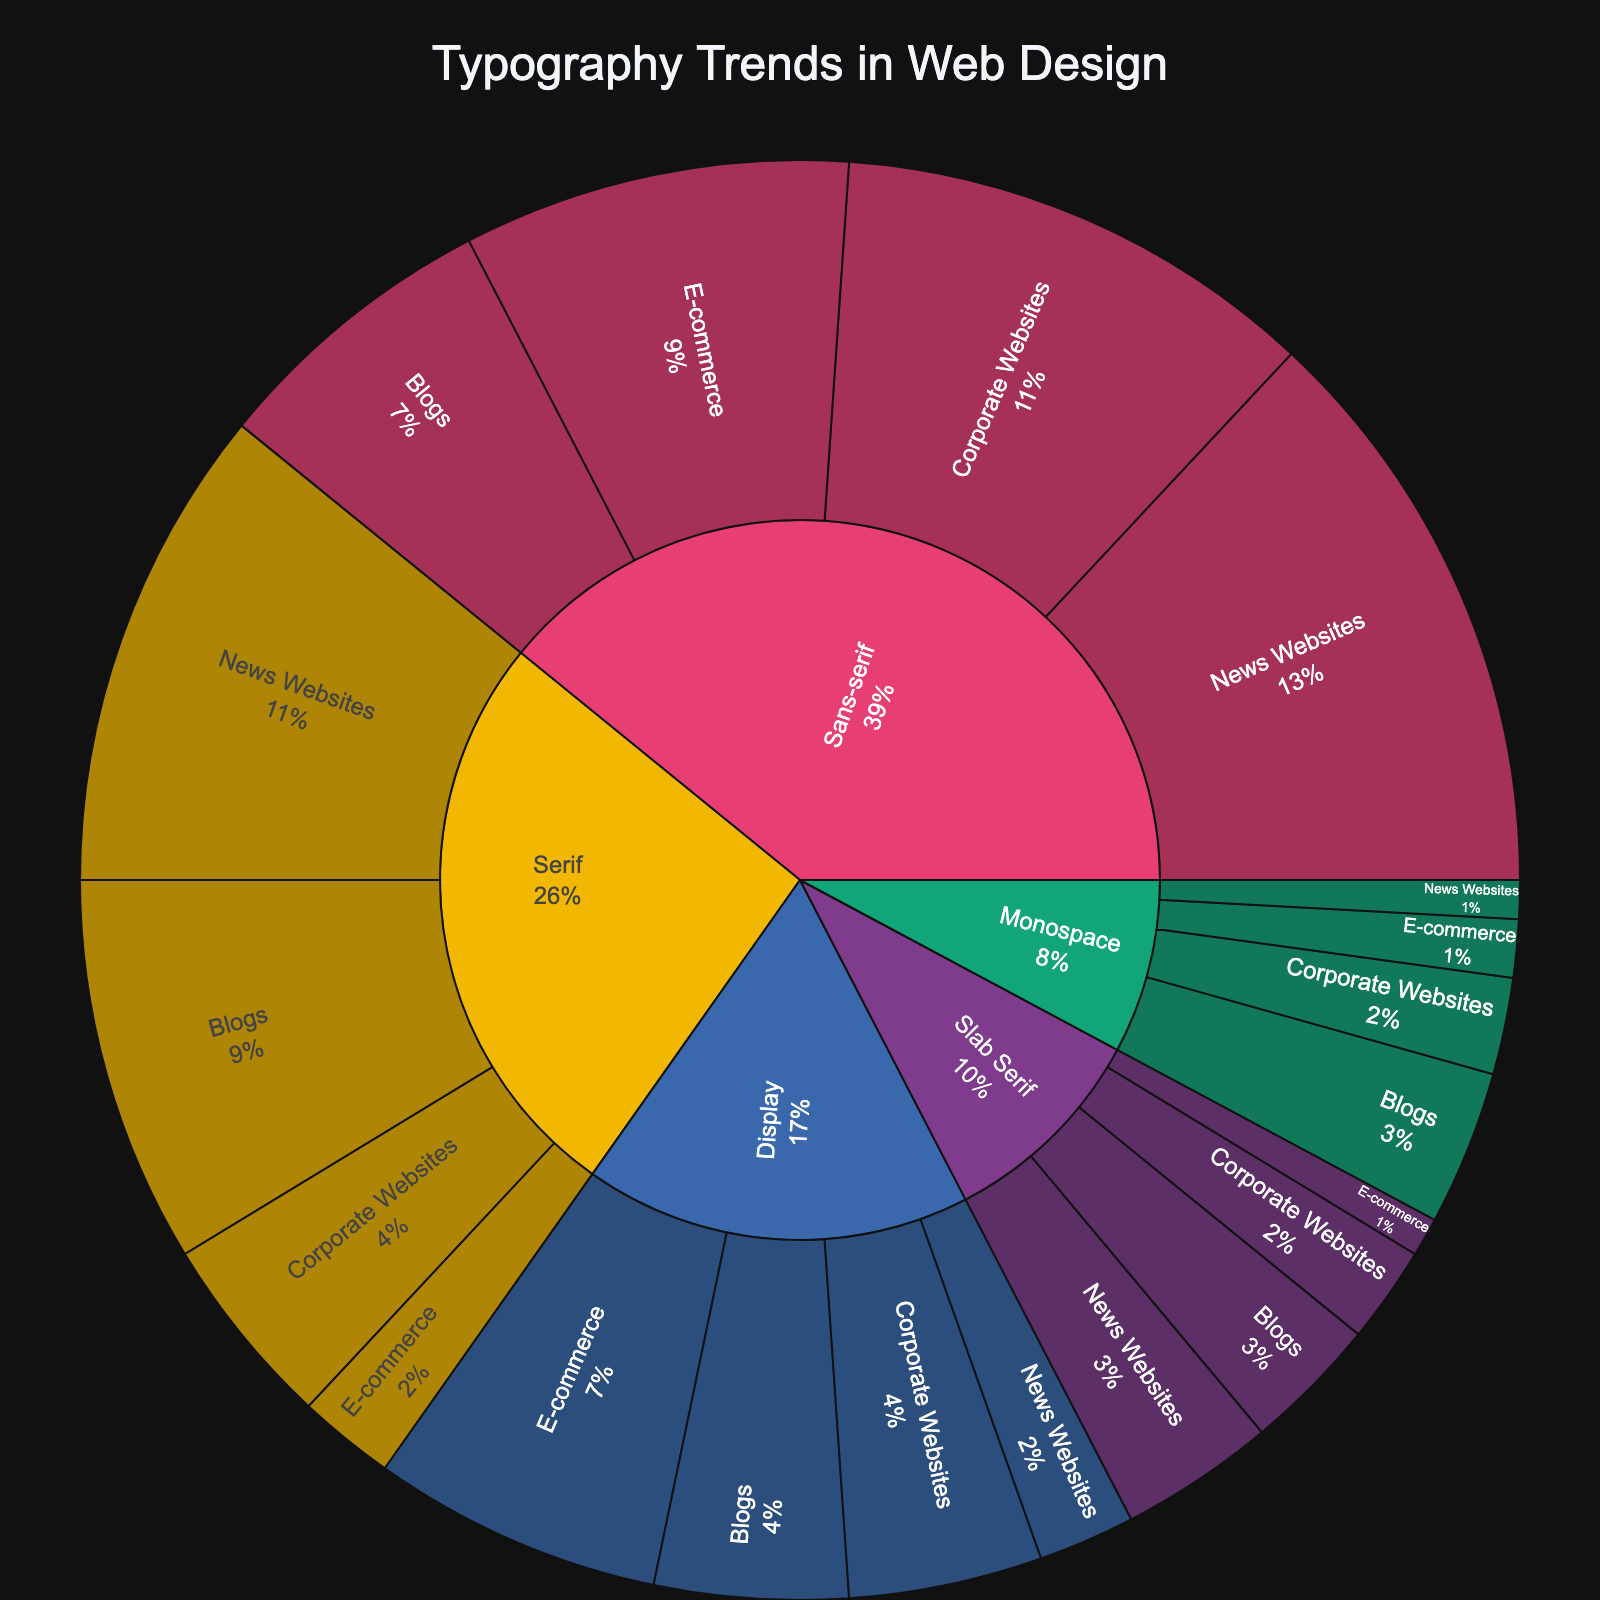What is the most frequently used font family across all website genres? Identify all subcategories within each category, sum up their values, and find the category with the highest total. Sans-serif has the highest total (30 + 25 + 20 + 15 = 90).
Answer: Sans-serif Which website genre uses Display fonts the most? Among the subcategories under Display, E-commerce has the highest value with 15.
Answer: E-commerce What is the percentage of Serif fonts used in News Websites compared to the total usage of all font families in News Websites? Calculate the total usage of fonts in News Websites (30 + 25 + 5 + 2 + 8 = 70). For Serif in News Websites, it is 25 out of 70, so the percentage is (25/70)*100 ≈ 35.7%.
Answer: 35.7% Between Serif and Slab Serif fonts, which has a higher usage in Blogs? Compare the values of Serif and Slab Serif in Blogs: Serif has 20, and Slab Serif has 7. Therefore, Serif has a higher usage.
Answer: Serif How many more times are display fonts used in E-commerce sites than in Corporate Websites? Divide the value for Display in E-commerce by the value in Corporate Websites (15 / 10 = 1.5). So, display fonts are used 1.5 times more in E-commerce sites than in Corporate Websites.
Answer: 1.5 times What is the proportion of websites using Monospace fonts to those using all other font families combined? Calculate the total usage of Monospace fonts (2 + 5 + 3 + 8 = 18). Calculate the sum of usage for all other fonts (90 + 60 + 40 + 22 = 212). The proportion is 18 / (18 + 212) = 18 / 230 ≈ 7.8%.
Answer: 7.8% Which font family is least used in Corporate Websites? Compare the values of all font families in Corporate Websites. Monospace has the lowest value with 5.
Answer: Monospace Which font family in News Websites has almost the same usage as Slab Serif in Blogs? Slab Serif in Blogs has a value of 7. Comparing other values in News Websites, closest is Monospace with a value of 2.
Answer: Monospace What is the combined usage of Sans-serif and Serif fonts in E-commerce websites? Add the values for Sans-serif and Serif in E-commerce (20 + 5 = 25).
Answer: 25 Which font family distribution is more balanced across all website genres? Calculate the standard deviation of usage in each category. Sans-serif has values (30, 25, 20, 15); Serif has (25, 10, 5, 20); Display has (5, 10, 15, 10); Monospace has (2, 5, 3, 8); Slab Serif has (8, 5, 2, 7). Display has the most balanced distribution with the lowest standard deviation.
Answer: Display 